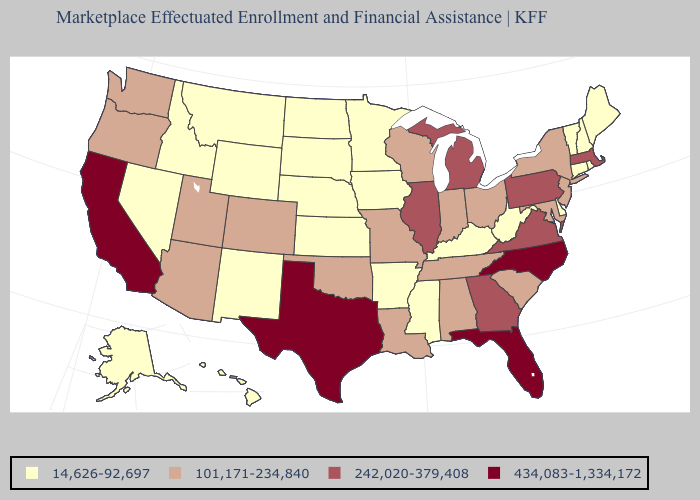Does Montana have the highest value in the West?
Give a very brief answer. No. Is the legend a continuous bar?
Keep it brief. No. What is the value of Wisconsin?
Quick response, please. 101,171-234,840. Does Georgia have a higher value than California?
Keep it brief. No. Name the states that have a value in the range 14,626-92,697?
Keep it brief. Alaska, Arkansas, Connecticut, Delaware, Hawaii, Idaho, Iowa, Kansas, Kentucky, Maine, Minnesota, Mississippi, Montana, Nebraska, Nevada, New Hampshire, New Mexico, North Dakota, Rhode Island, South Dakota, Vermont, West Virginia, Wyoming. Among the states that border Georgia , does Tennessee have the lowest value?
Be succinct. Yes. What is the lowest value in states that border Rhode Island?
Answer briefly. 14,626-92,697. What is the value of Vermont?
Quick response, please. 14,626-92,697. Does Maryland have a lower value than Illinois?
Keep it brief. Yes. What is the value of Texas?
Write a very short answer. 434,083-1,334,172. Which states have the lowest value in the West?
Answer briefly. Alaska, Hawaii, Idaho, Montana, Nevada, New Mexico, Wyoming. Which states have the lowest value in the USA?
Concise answer only. Alaska, Arkansas, Connecticut, Delaware, Hawaii, Idaho, Iowa, Kansas, Kentucky, Maine, Minnesota, Mississippi, Montana, Nebraska, Nevada, New Hampshire, New Mexico, North Dakota, Rhode Island, South Dakota, Vermont, West Virginia, Wyoming. Among the states that border Massachusetts , does New York have the highest value?
Keep it brief. Yes. Which states have the highest value in the USA?
Write a very short answer. California, Florida, North Carolina, Texas. 